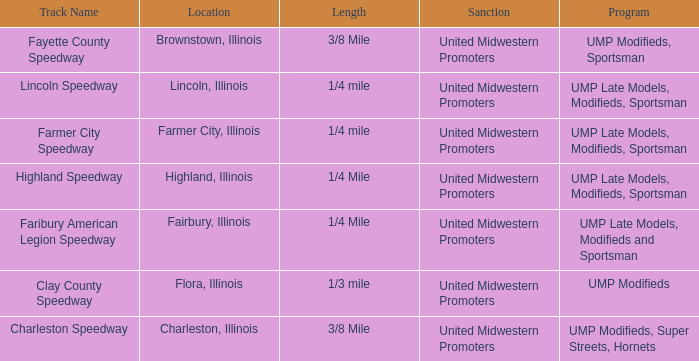What programs were held in charleston, illinois? UMP Modifieds, Super Streets, Hornets. 